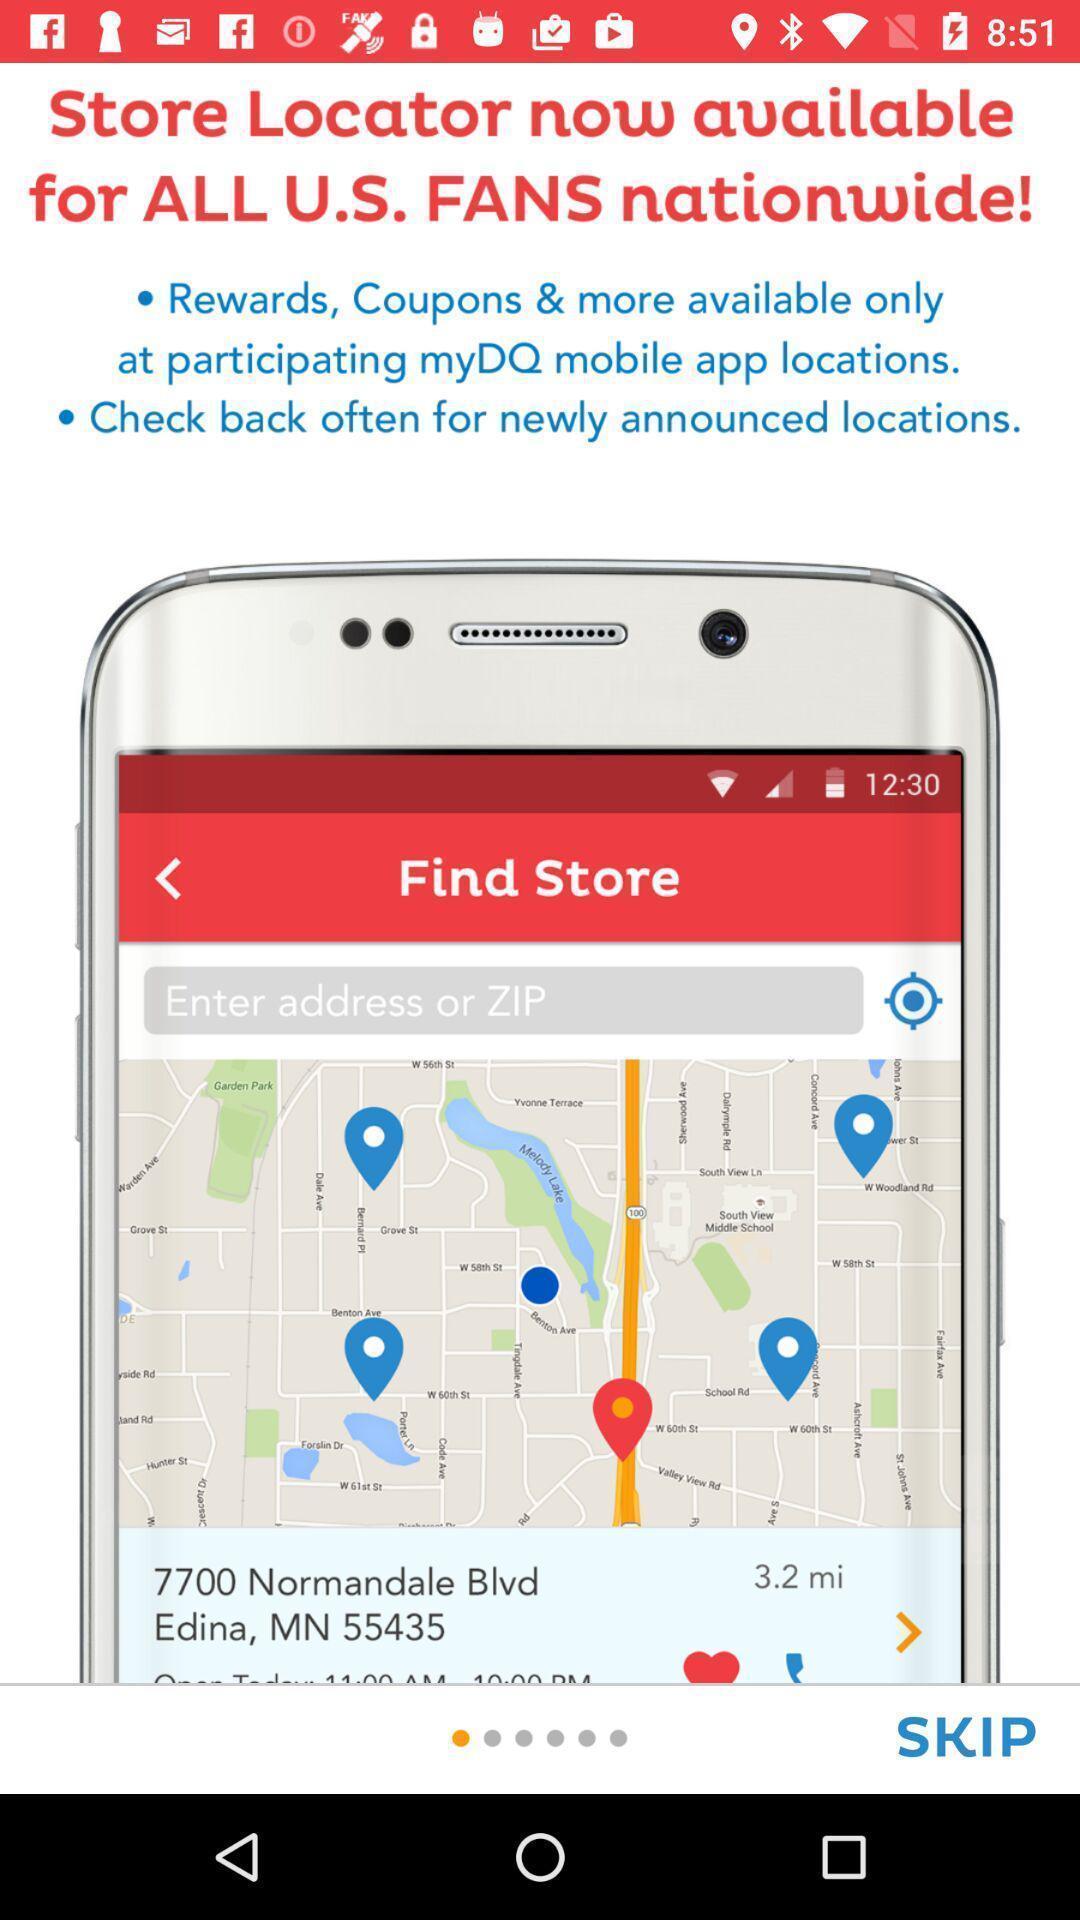Give me a narrative description of this picture. Welcome screen showing updates and details. 